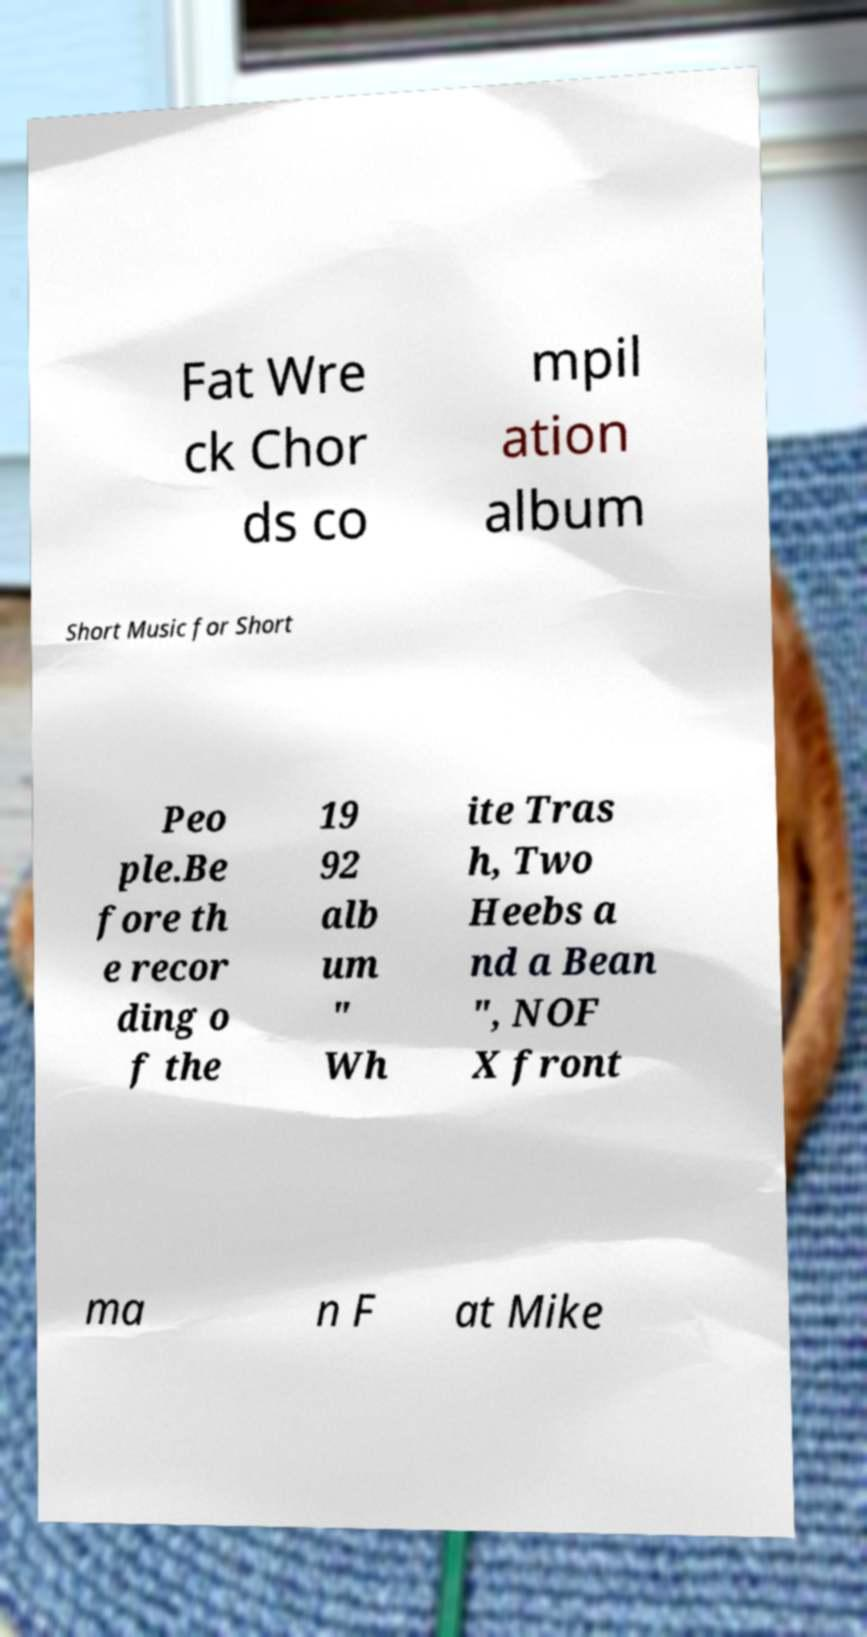For documentation purposes, I need the text within this image transcribed. Could you provide that? Fat Wre ck Chor ds co mpil ation album Short Music for Short Peo ple.Be fore th e recor ding o f the 19 92 alb um " Wh ite Tras h, Two Heebs a nd a Bean ", NOF X front ma n F at Mike 